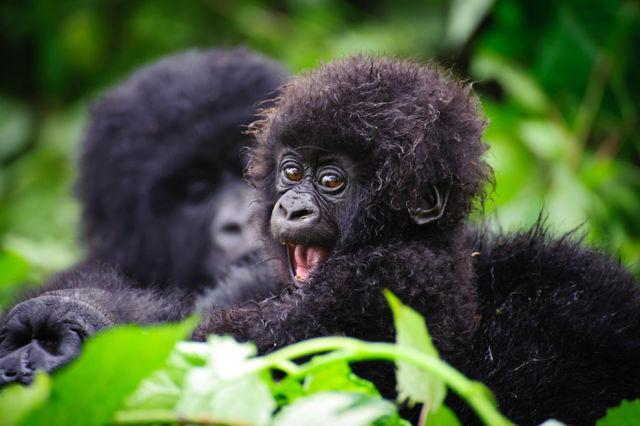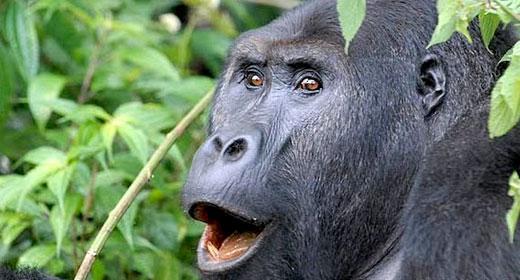The first image is the image on the left, the second image is the image on the right. For the images shown, is this caption "One image has a young ape along with an adult." true? Answer yes or no. Yes. The first image is the image on the left, the second image is the image on the right. Given the left and right images, does the statement "There is a baby primate with an adult primate." hold true? Answer yes or no. Yes. 